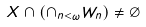<formula> <loc_0><loc_0><loc_500><loc_500>X \cap ( \cap _ { n < \omega } W _ { n } ) \ne \emptyset</formula> 